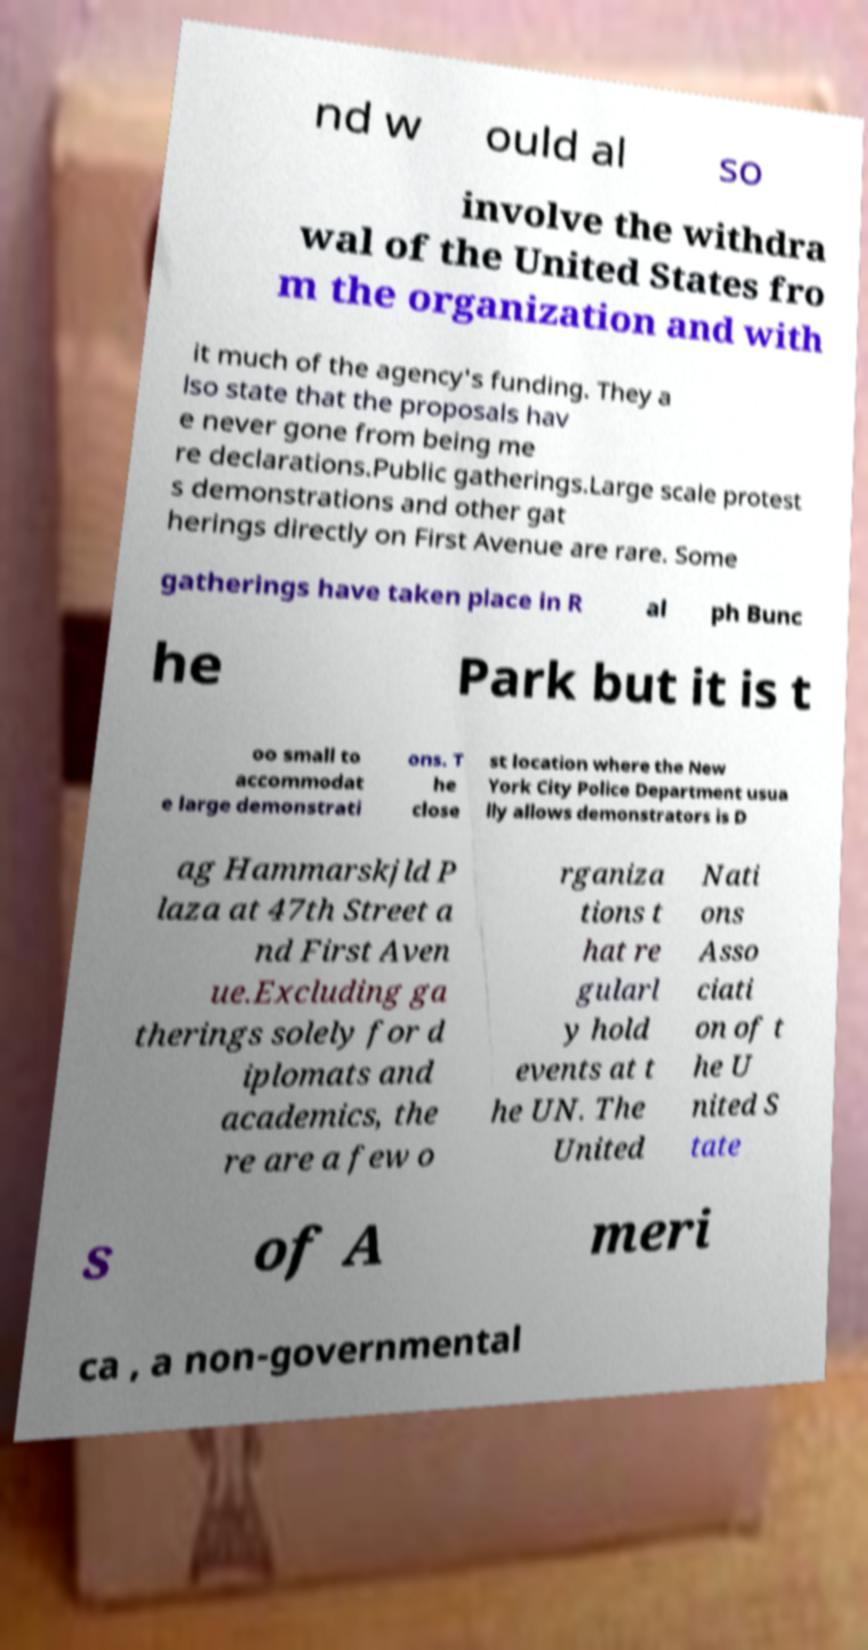There's text embedded in this image that I need extracted. Can you transcribe it verbatim? nd w ould al so involve the withdra wal of the United States fro m the organization and with it much of the agency's funding. They a lso state that the proposals hav e never gone from being me re declarations.Public gatherings.Large scale protest s demonstrations and other gat herings directly on First Avenue are rare. Some gatherings have taken place in R al ph Bunc he Park but it is t oo small to accommodat e large demonstrati ons. T he close st location where the New York City Police Department usua lly allows demonstrators is D ag Hammarskjld P laza at 47th Street a nd First Aven ue.Excluding ga therings solely for d iplomats and academics, the re are a few o rganiza tions t hat re gularl y hold events at t he UN. The United Nati ons Asso ciati on of t he U nited S tate s of A meri ca , a non-governmental 